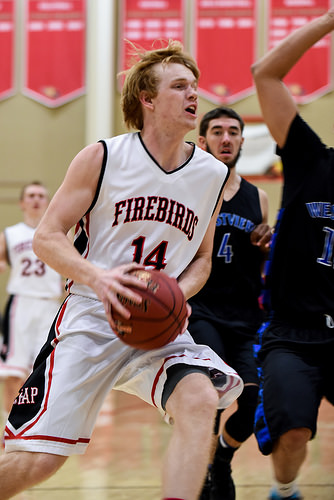<image>
Is there a wall behind the ball? Yes. From this viewpoint, the wall is positioned behind the ball, with the ball partially or fully occluding the wall. 